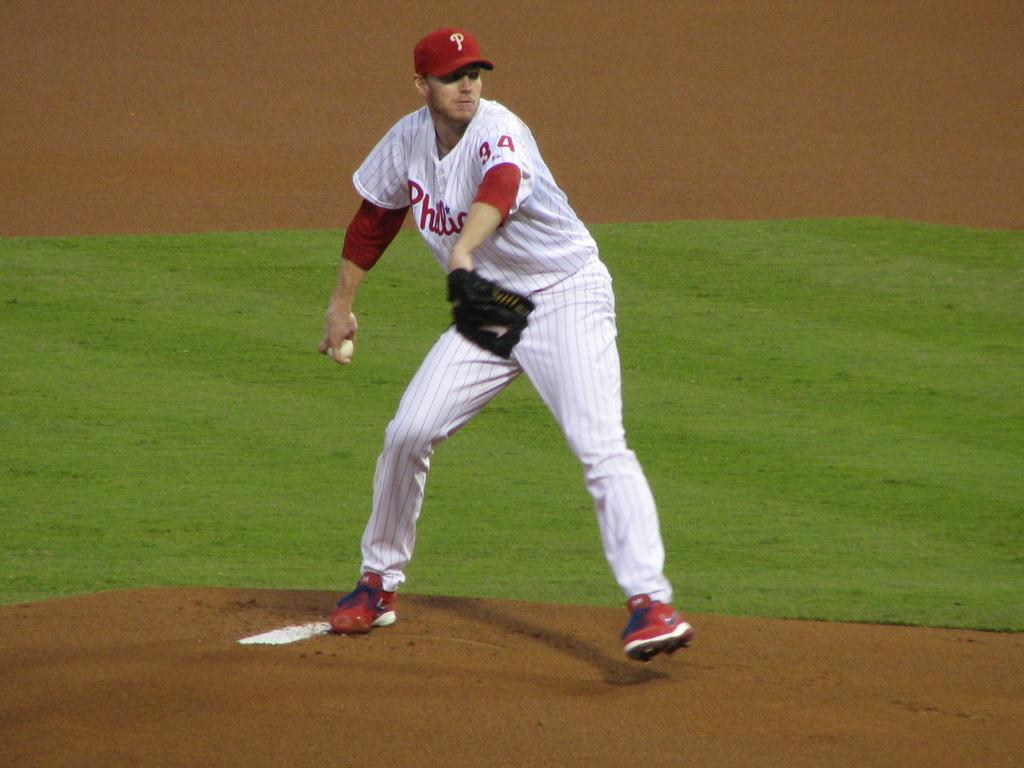<image>
Present a compact description of the photo's key features. A baseball player with the letter h on his jersey is about to throw the ball. 